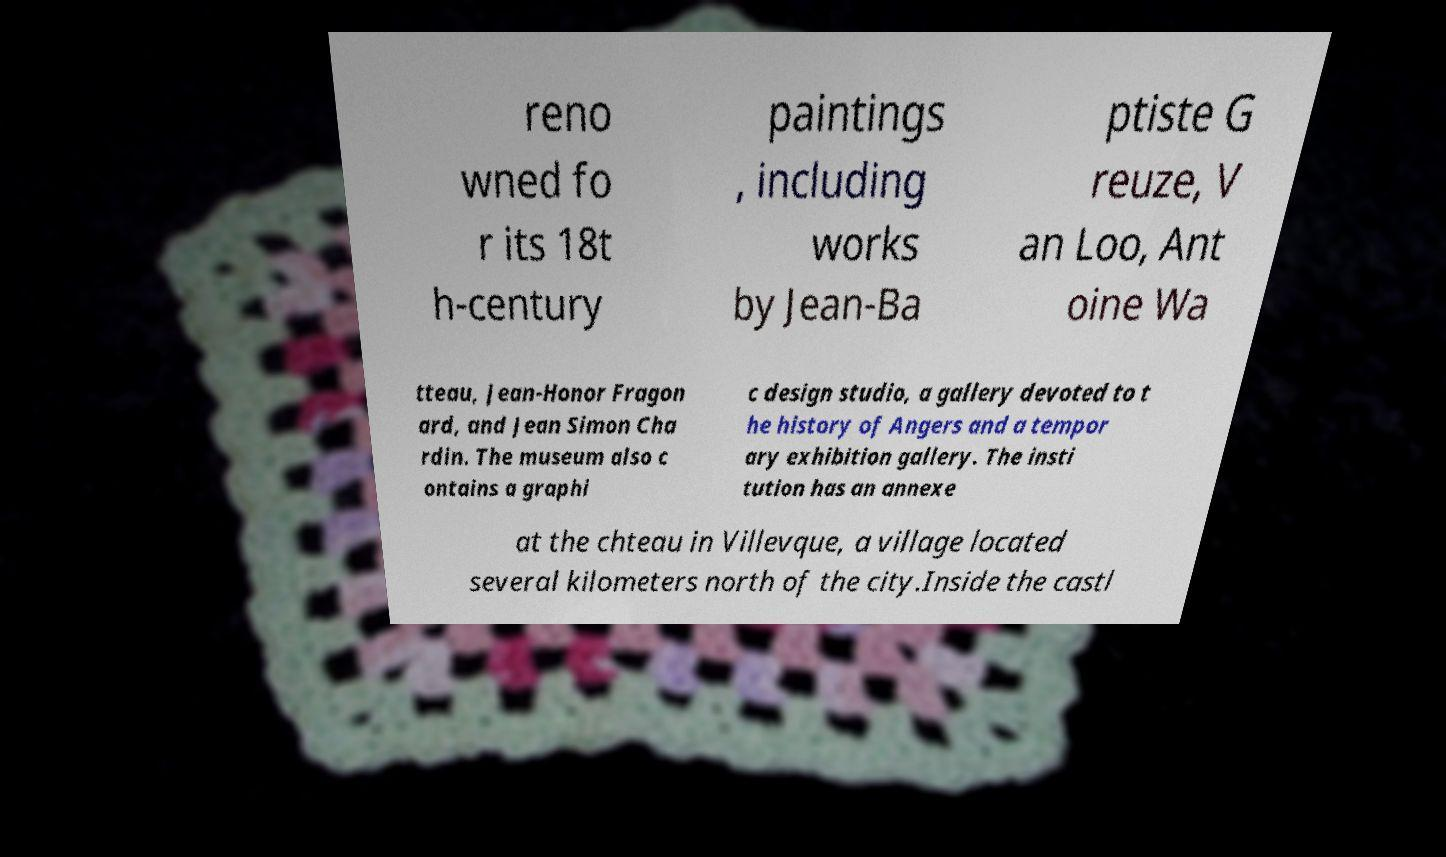Please read and relay the text visible in this image. What does it say? reno wned fo r its 18t h-century paintings , including works by Jean-Ba ptiste G reuze, V an Loo, Ant oine Wa tteau, Jean-Honor Fragon ard, and Jean Simon Cha rdin. The museum also c ontains a graphi c design studio, a gallery devoted to t he history of Angers and a tempor ary exhibition gallery. The insti tution has an annexe at the chteau in Villevque, a village located several kilometers north of the city.Inside the castl 